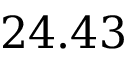Convert formula to latex. <formula><loc_0><loc_0><loc_500><loc_500>2 4 . 4 3</formula> 